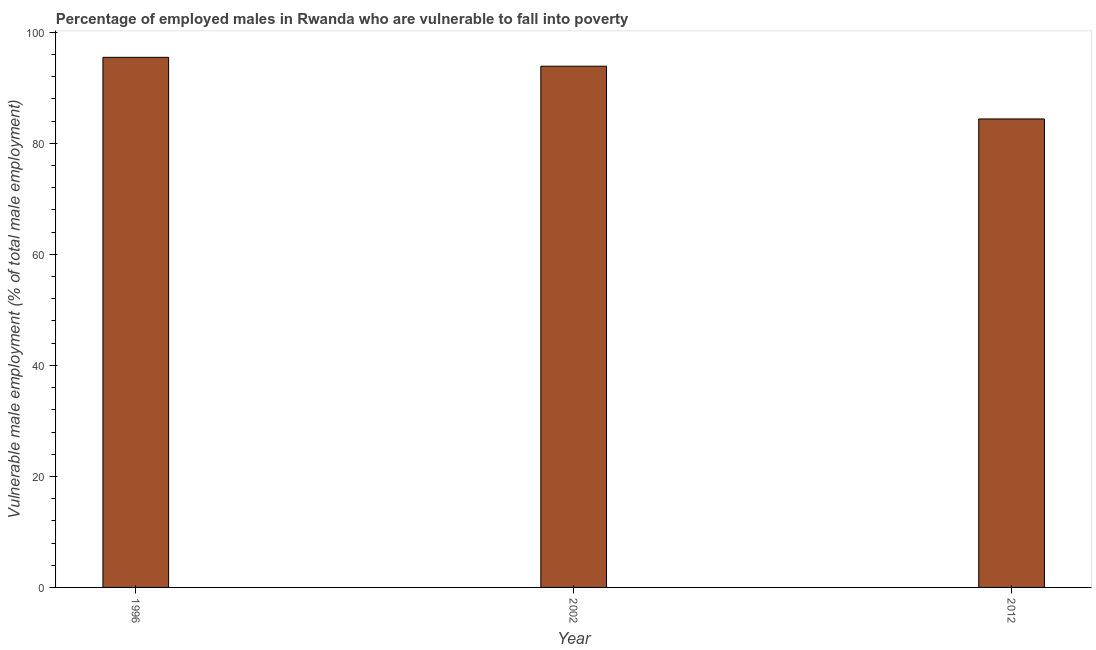Does the graph contain grids?
Ensure brevity in your answer.  No. What is the title of the graph?
Your answer should be compact. Percentage of employed males in Rwanda who are vulnerable to fall into poverty. What is the label or title of the Y-axis?
Make the answer very short. Vulnerable male employment (% of total male employment). What is the percentage of employed males who are vulnerable to fall into poverty in 1996?
Ensure brevity in your answer.  95.5. Across all years, what is the maximum percentage of employed males who are vulnerable to fall into poverty?
Your answer should be very brief. 95.5. Across all years, what is the minimum percentage of employed males who are vulnerable to fall into poverty?
Offer a very short reply. 84.4. In which year was the percentage of employed males who are vulnerable to fall into poverty maximum?
Provide a short and direct response. 1996. In which year was the percentage of employed males who are vulnerable to fall into poverty minimum?
Provide a succinct answer. 2012. What is the sum of the percentage of employed males who are vulnerable to fall into poverty?
Your answer should be very brief. 273.8. What is the average percentage of employed males who are vulnerable to fall into poverty per year?
Make the answer very short. 91.27. What is the median percentage of employed males who are vulnerable to fall into poverty?
Give a very brief answer. 93.9. In how many years, is the percentage of employed males who are vulnerable to fall into poverty greater than 44 %?
Give a very brief answer. 3. Do a majority of the years between 2002 and 1996 (inclusive) have percentage of employed males who are vulnerable to fall into poverty greater than 24 %?
Offer a terse response. No. What is the ratio of the percentage of employed males who are vulnerable to fall into poverty in 1996 to that in 2002?
Your response must be concise. 1.02. What is the difference between the highest and the second highest percentage of employed males who are vulnerable to fall into poverty?
Your answer should be very brief. 1.6. In how many years, is the percentage of employed males who are vulnerable to fall into poverty greater than the average percentage of employed males who are vulnerable to fall into poverty taken over all years?
Provide a succinct answer. 2. How many bars are there?
Offer a very short reply. 3. What is the difference between two consecutive major ticks on the Y-axis?
Provide a succinct answer. 20. What is the Vulnerable male employment (% of total male employment) of 1996?
Your answer should be compact. 95.5. What is the Vulnerable male employment (% of total male employment) in 2002?
Provide a succinct answer. 93.9. What is the Vulnerable male employment (% of total male employment) in 2012?
Make the answer very short. 84.4. What is the difference between the Vulnerable male employment (% of total male employment) in 1996 and 2012?
Make the answer very short. 11.1. What is the difference between the Vulnerable male employment (% of total male employment) in 2002 and 2012?
Provide a short and direct response. 9.5. What is the ratio of the Vulnerable male employment (% of total male employment) in 1996 to that in 2012?
Your response must be concise. 1.13. What is the ratio of the Vulnerable male employment (% of total male employment) in 2002 to that in 2012?
Offer a terse response. 1.11. 